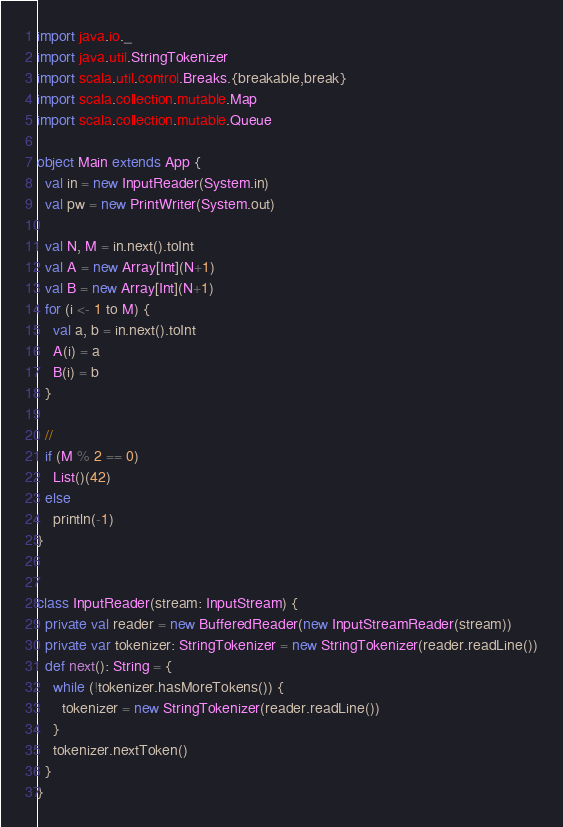Convert code to text. <code><loc_0><loc_0><loc_500><loc_500><_Scala_>import java.io._
import java.util.StringTokenizer
import scala.util.control.Breaks.{breakable,break}
import scala.collection.mutable.Map
import scala.collection.mutable.Queue

object Main extends App {
  val in = new InputReader(System.in)
  val pw = new PrintWriter(System.out)

  val N, M = in.next().toInt
  val A = new Array[Int](N+1)
  val B = new Array[Int](N+1)
  for (i <- 1 to M) {
    val a, b = in.next().toInt
    A(i) = a
    B(i) = b
  }

  //
  if (M % 2 == 0)
    List()(42)
  else
    println(-1)
}


class InputReader(stream: InputStream) {
  private val reader = new BufferedReader(new InputStreamReader(stream))
  private var tokenizer: StringTokenizer = new StringTokenizer(reader.readLine())
  def next(): String = {
    while (!tokenizer.hasMoreTokens()) {
      tokenizer = new StringTokenizer(reader.readLine())
    }
    tokenizer.nextToken()
  }
}
</code> 